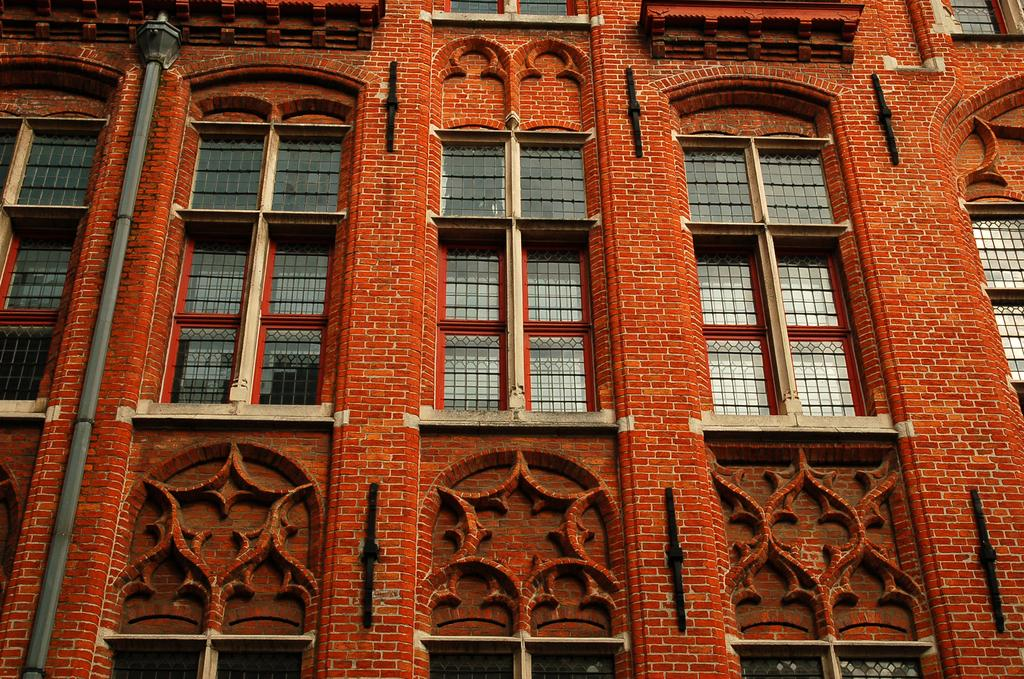What type of structure is present in the image? There is a building in the image. What feature can be seen on the building? The building has windows. What other object is visible in the image? There is a light pole in the image. Can you tell me how many yokes are attached to the light pole in the image? There are no yokes present or attached to the light pole in the image. Is the building located near a harbor in the image? There is no information about a harbor in the image, as it only features a building and a light pole. 